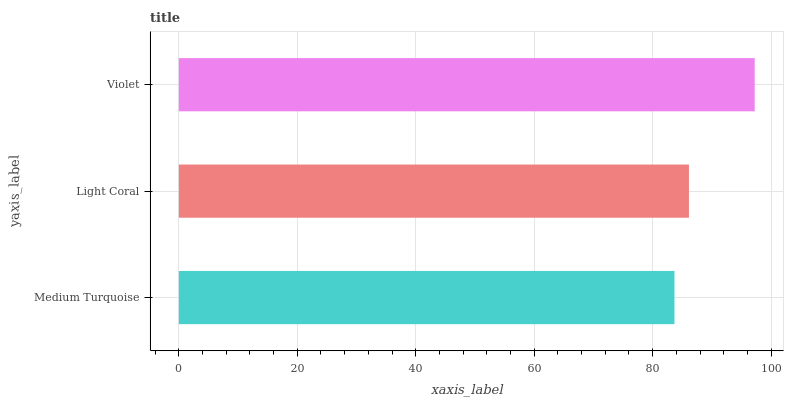Is Medium Turquoise the minimum?
Answer yes or no. Yes. Is Violet the maximum?
Answer yes or no. Yes. Is Light Coral the minimum?
Answer yes or no. No. Is Light Coral the maximum?
Answer yes or no. No. Is Light Coral greater than Medium Turquoise?
Answer yes or no. Yes. Is Medium Turquoise less than Light Coral?
Answer yes or no. Yes. Is Medium Turquoise greater than Light Coral?
Answer yes or no. No. Is Light Coral less than Medium Turquoise?
Answer yes or no. No. Is Light Coral the high median?
Answer yes or no. Yes. Is Light Coral the low median?
Answer yes or no. Yes. Is Medium Turquoise the high median?
Answer yes or no. No. Is Violet the low median?
Answer yes or no. No. 